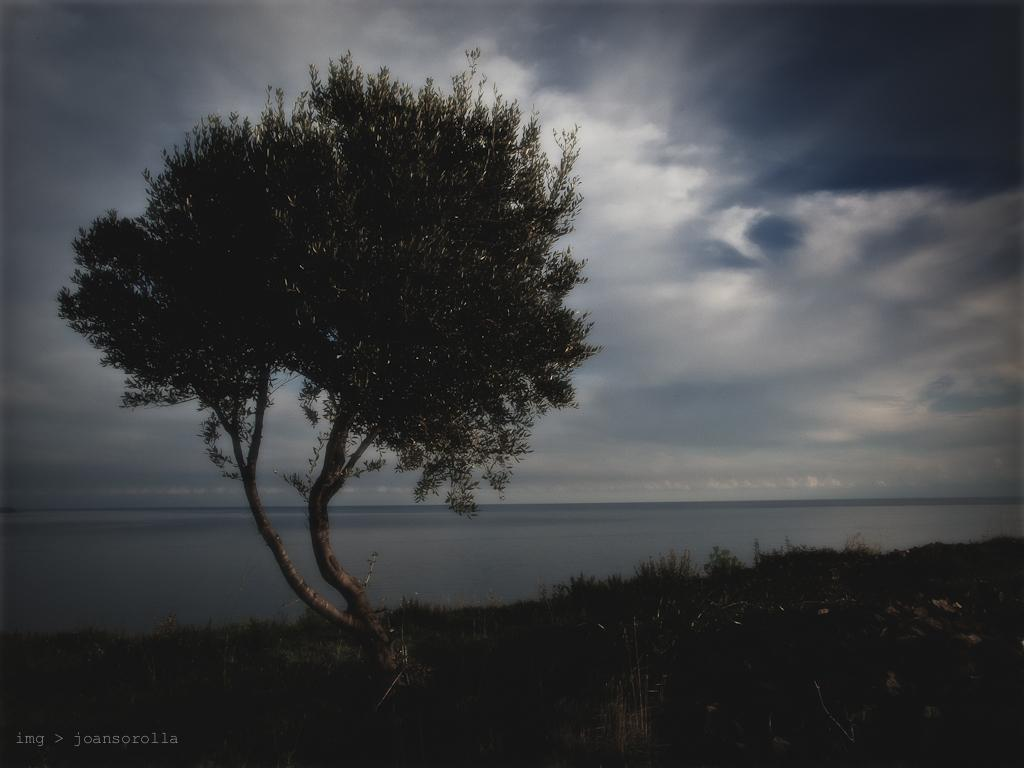What type of vegetation is present in the image? There is grass in the image. Are there any other natural elements in the image? Yes, there is a tree in the image. What can be seen in the background of the image? Water and the sky are visible in the background of the image. What is the condition of the sky in the image? Clouds are present in the sky. Is there any text or marking in the image? Yes, there is a watermark in the bottom left side of the image. Can you tell me how many quarters are visible in the image? There are no quarters present in the image. Is there a dog interacting with the tree in the image? There is no dog present in the image. 